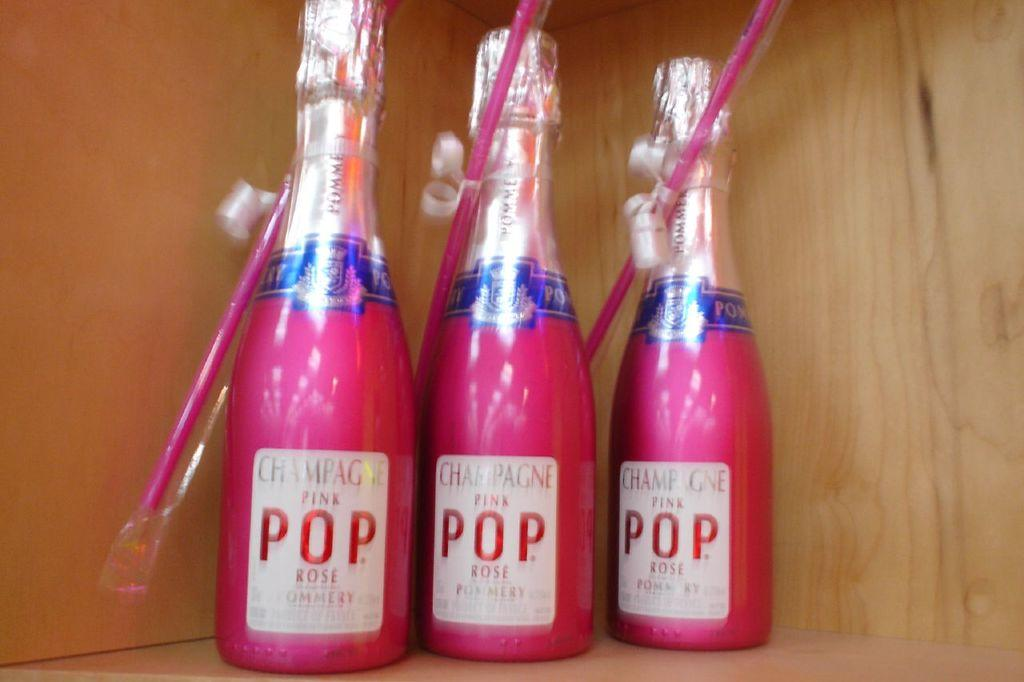<image>
Provide a brief description of the given image. Three bottles of Champagne Pink Pop sit on a shelf. 